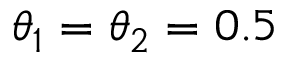Convert formula to latex. <formula><loc_0><loc_0><loc_500><loc_500>{ \theta } _ { 1 } = { \theta } _ { 2 } = 0 . 5</formula> 